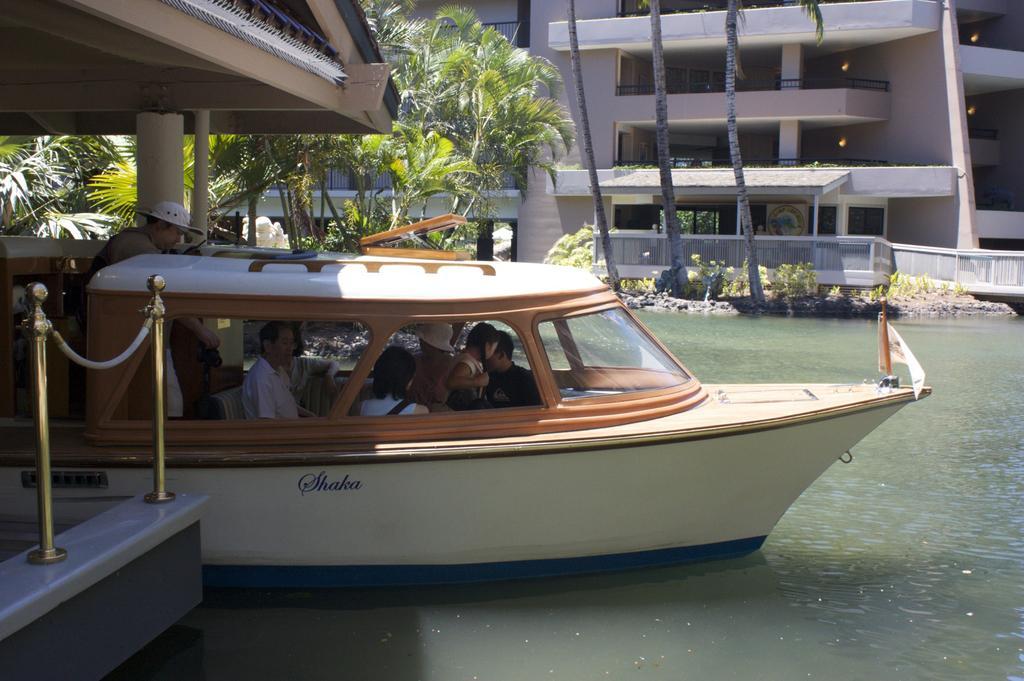Could you give a brief overview of what you see in this image? In the center of the image there is boat there are people sitting in it. In the background of the image there is a building. There are trees. At the bottom of the image there is water. 